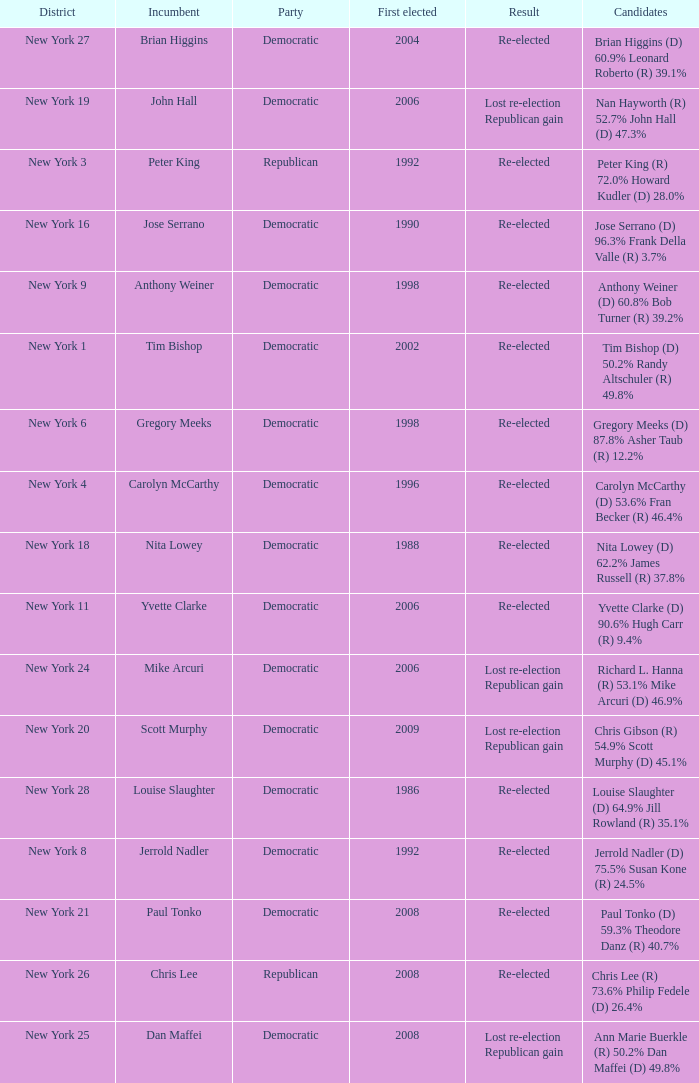Name the result for new york 8 Re-elected. 